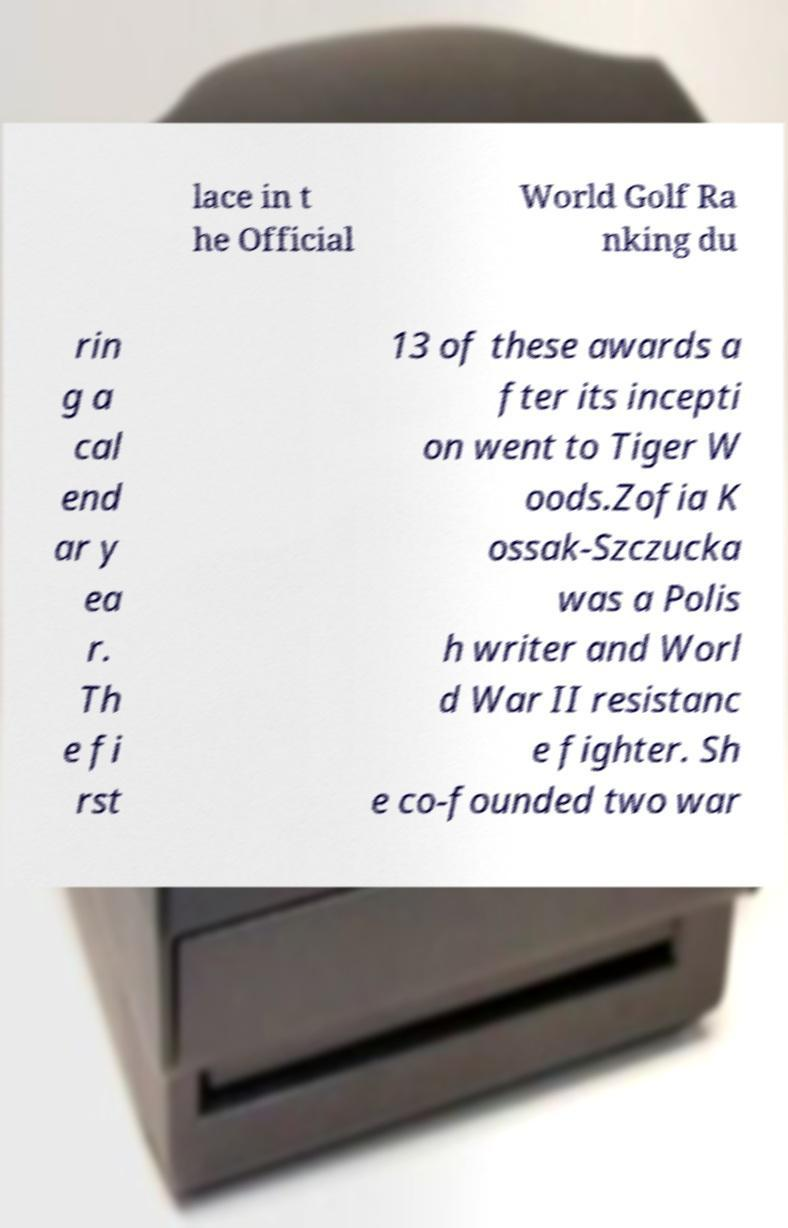For documentation purposes, I need the text within this image transcribed. Could you provide that? lace in t he Official World Golf Ra nking du rin g a cal end ar y ea r. Th e fi rst 13 of these awards a fter its incepti on went to Tiger W oods.Zofia K ossak-Szczucka was a Polis h writer and Worl d War II resistanc e fighter. Sh e co-founded two war 